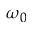<formula> <loc_0><loc_0><loc_500><loc_500>\omega _ { 0 }</formula> 